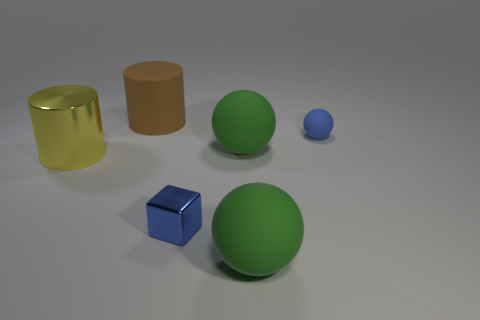Are the shapes rendered with realistic lighting and shadows? The shapes are indeed rendered with lighting and shadows that suggest a consistent light source, giving them a three-dimensional appearance. 